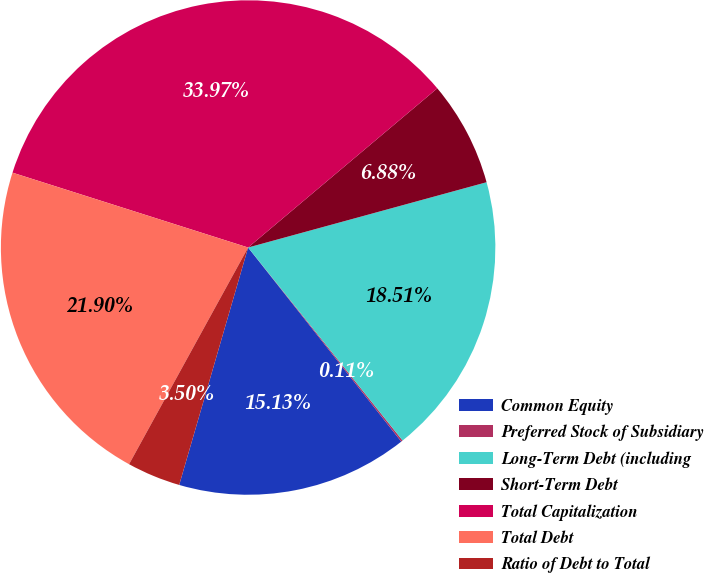<chart> <loc_0><loc_0><loc_500><loc_500><pie_chart><fcel>Common Equity<fcel>Preferred Stock of Subsidiary<fcel>Long-Term Debt (including<fcel>Short-Term Debt<fcel>Total Capitalization<fcel>Total Debt<fcel>Ratio of Debt to Total<nl><fcel>15.13%<fcel>0.11%<fcel>18.51%<fcel>6.88%<fcel>33.97%<fcel>21.9%<fcel>3.5%<nl></chart> 